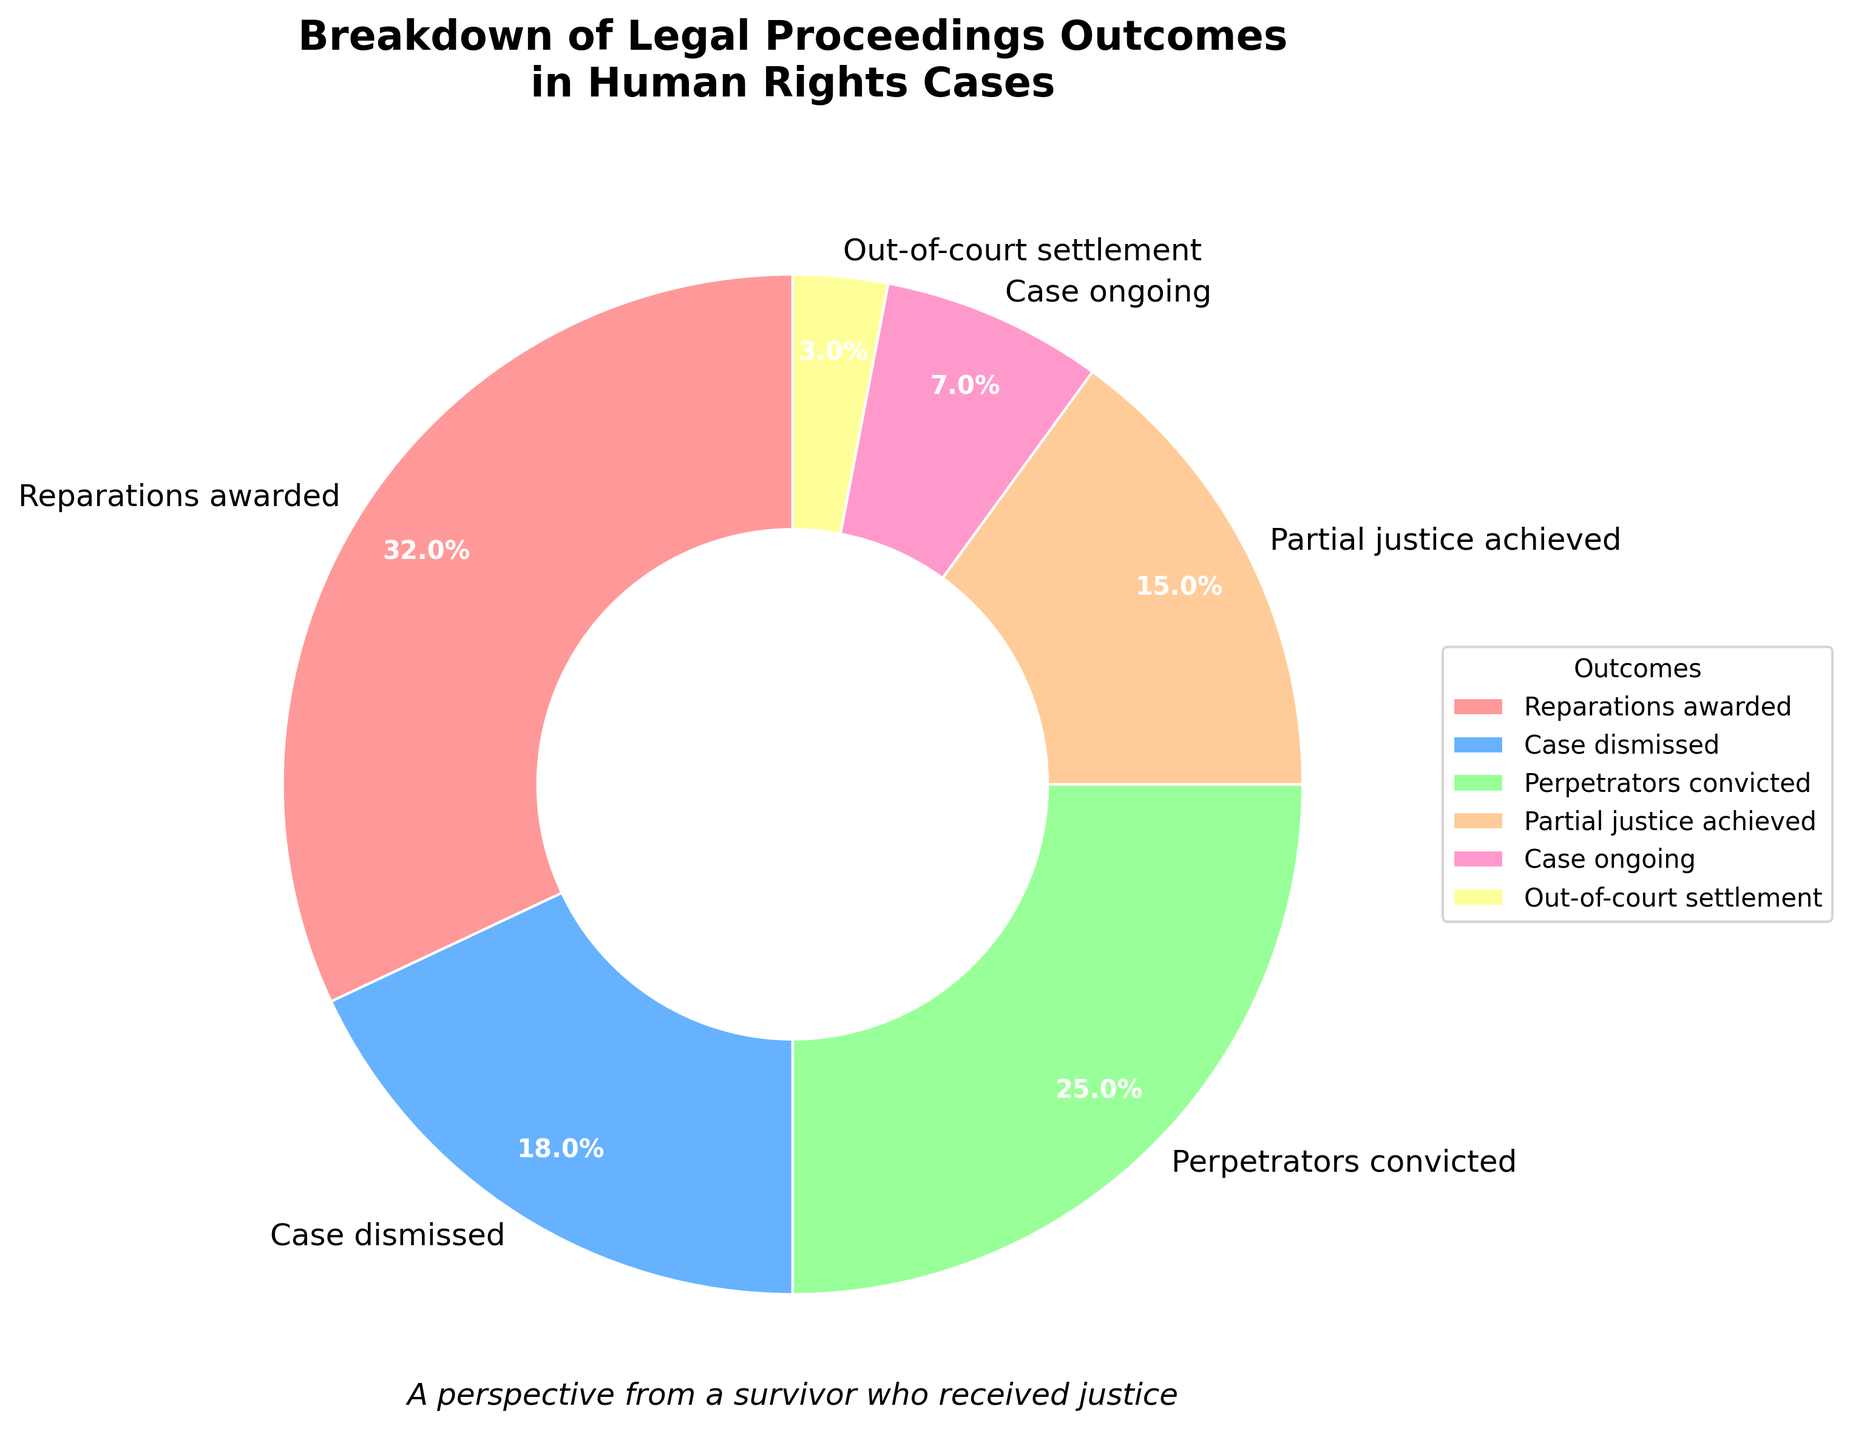What's the highest percentage outcome in the pie chart? The pie chart shows the percentages of different outcomes. The outcome with the highest percentage is easily visible as it takes up the largest portion of the pie. "Reparations awarded" is the largest segment.
Answer: Reparations awarded Which outcomes have a smaller percentage than 'Perpetrators convicted'? To determine this, compare the percentage of 'Perpetrators convicted' (25%) with the other outcomes. Outcomes with smaller percentages than 25% include 'Case dismissed', 'Partial justice achieved', 'Case ongoing', and 'Out-of-court settlement'.
Answer: Case dismissed, Partial justice achieved, Case ongoing, Out-of-court settlement What is the combined percentage of 'Case ongoing' and 'Out-of-court settlement'? Add the percentages for 'Case ongoing' (7%) and 'Out-of-court settlement' (3%). The combined percentage is 7 + 3 = 10%.
Answer: 10% If you combine 'Reparations awarded' and 'Perpetrators convicted', what percentage of cases do these two outcomes represent? Add up the percentages of 'Reparations awarded' (32%) and 'Perpetrators convicted' (25%). The total is 32 + 25 = 57%.
Answer: 57% Identify the outcome represented by the yellow-color part of the pie chart. By observing the pie chart, the yellow-colored segment coincides with the label 'Out-of-court settlement', placed next to it.
Answer: Out-of-court settlement How does 'Partial justice achieved' compare with 'Case dismissed'? Compare the percentages of 'Partial justice achieved' (15%) with 'Case dismissed' (18%). 'Partial justice achieved' has a lower percentage.
Answer: Less than What's the difference in percentage between 'Reparations awarded' and 'Case dismissed'? Subtract the percentage of 'Case dismissed' (18%) from 'Reparations awarded' (32%). The difference is 32 - 18 = 14%.
Answer: 14% What is the total percentage of outcomes other than 'Reparations awarded'? Subtract the percentage of 'Reparations awarded' (32%) from 100%. The total is 100 - 32 = 68%.
Answer: 68% Estimate the average percentage for the outcomes 'Case dismissed', 'Partial justice achieved', and 'Case ongoing'. Add the percentages of 'Case dismissed' (18%), 'Partial justice achieved' (15%), and 'Case ongoing' (7%), then divide by 3. The average is (18 + 15 + 7) / 3 = 13.33%.
Answer: 13.33% Which outcome has the smallest representation in this chart? Identify the outcome with the smallest percentage. 'Out-of-court settlement' has the smallest representation at 3%.
Answer: Out-of-court settlement 